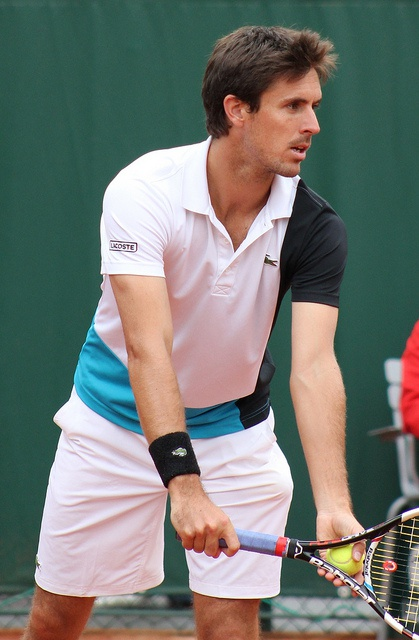Describe the objects in this image and their specific colors. I can see people in teal, lavender, lightpink, black, and brown tones, tennis racket in teal, black, gray, darkgray, and khaki tones, bench in teal, darkgray, and gray tones, and sports ball in teal, khaki, olive, and tan tones in this image. 